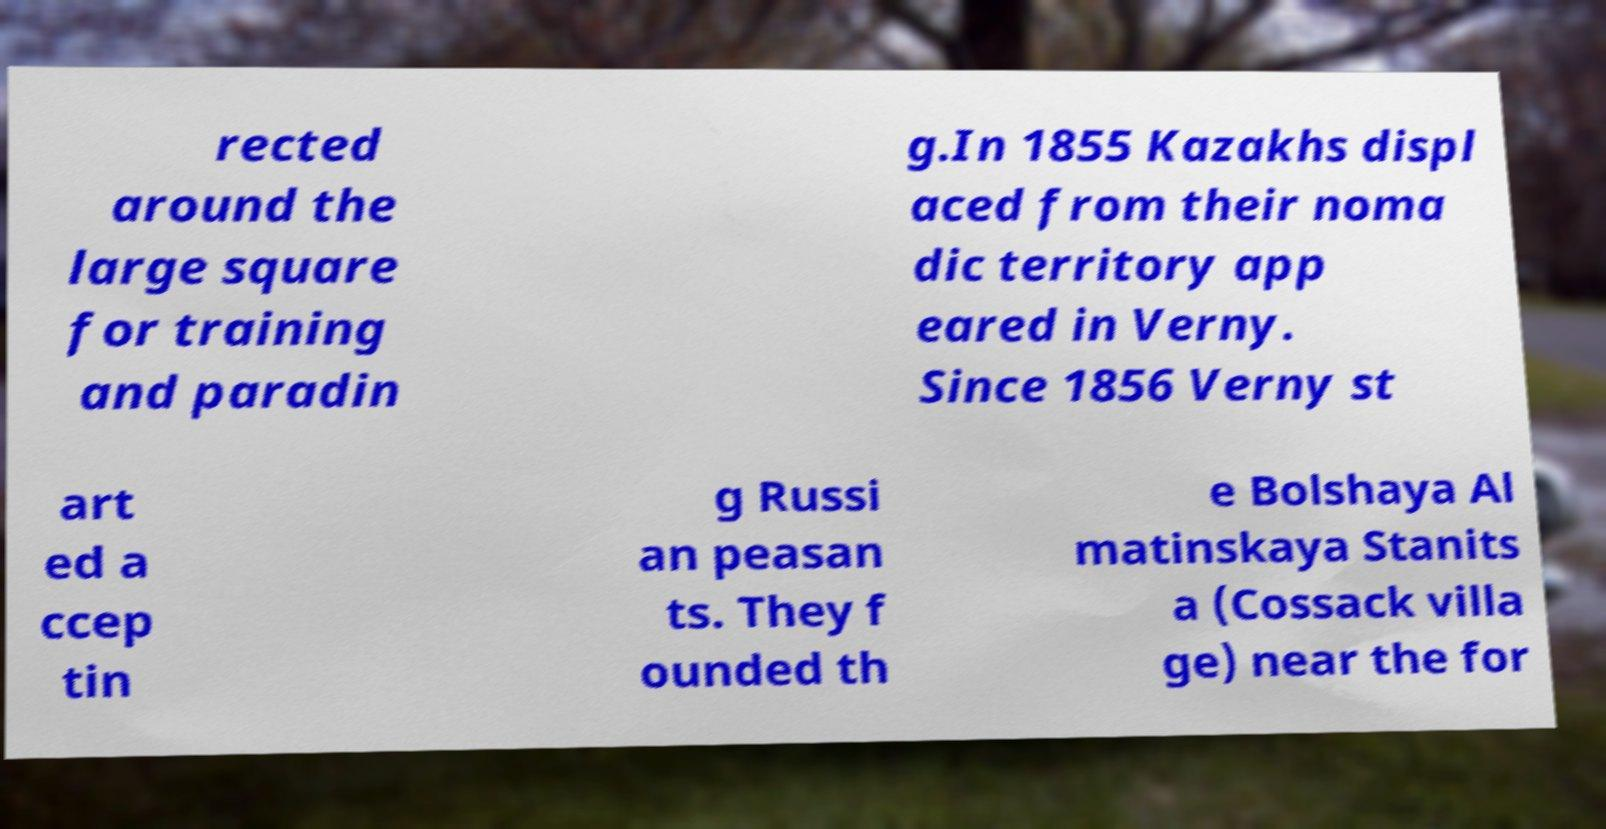What messages or text are displayed in this image? I need them in a readable, typed format. rected around the large square for training and paradin g.In 1855 Kazakhs displ aced from their noma dic territory app eared in Verny. Since 1856 Verny st art ed a ccep tin g Russi an peasan ts. They f ounded th e Bolshaya Al matinskaya Stanits a (Cossack villa ge) near the for 